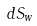<formula> <loc_0><loc_0><loc_500><loc_500>d S _ { w }</formula> 